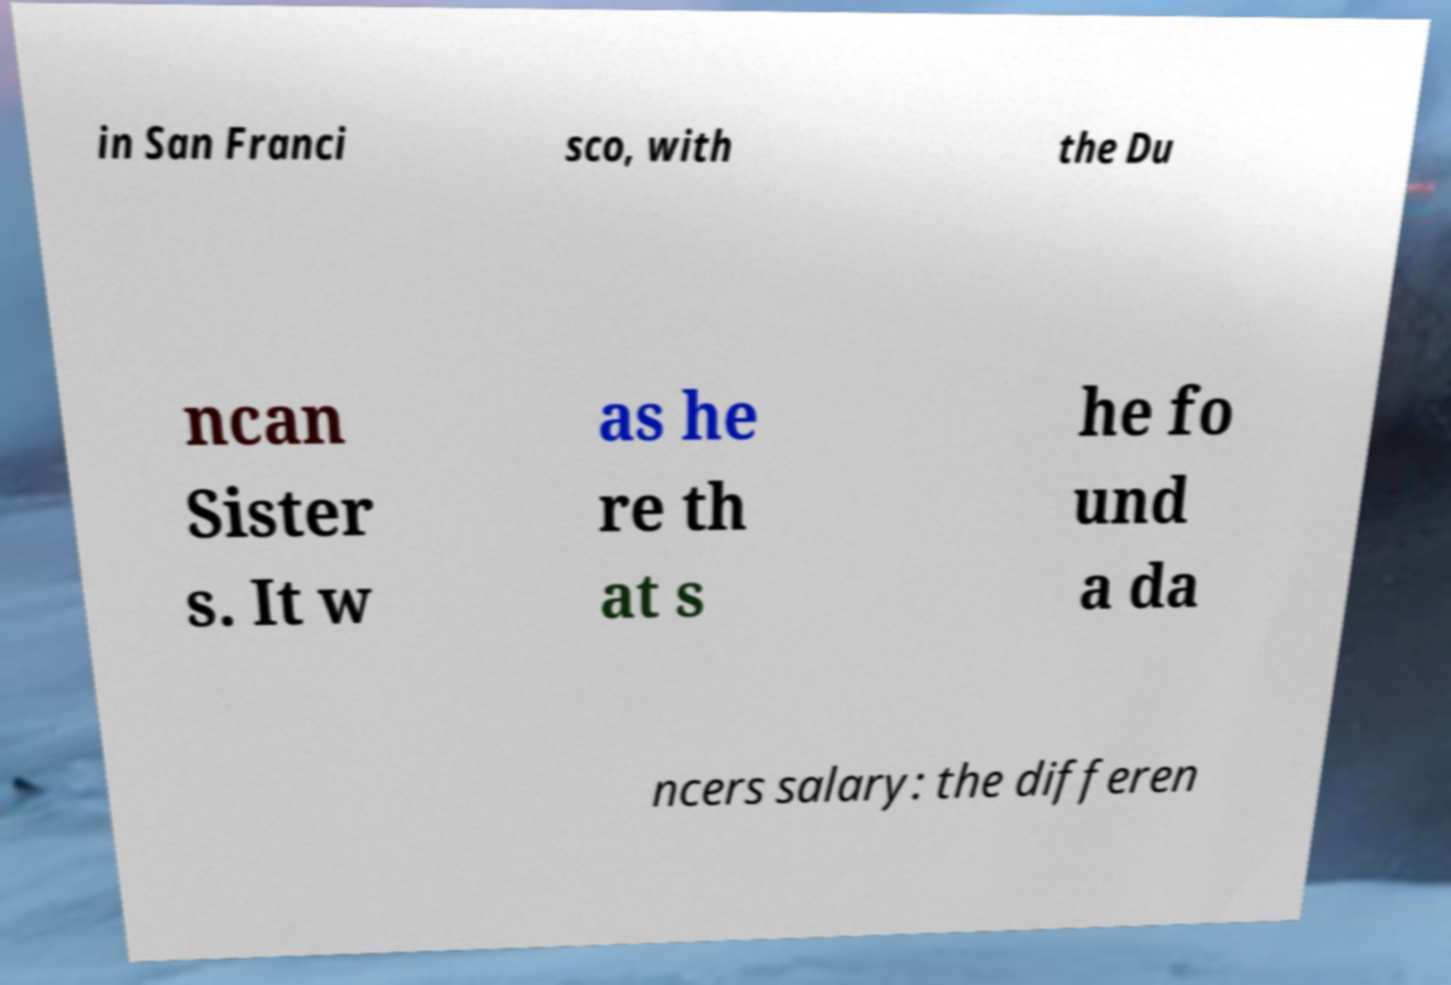Can you read and provide the text displayed in the image?This photo seems to have some interesting text. Can you extract and type it out for me? in San Franci sco, with the Du ncan Sister s. It w as he re th at s he fo und a da ncers salary: the differen 